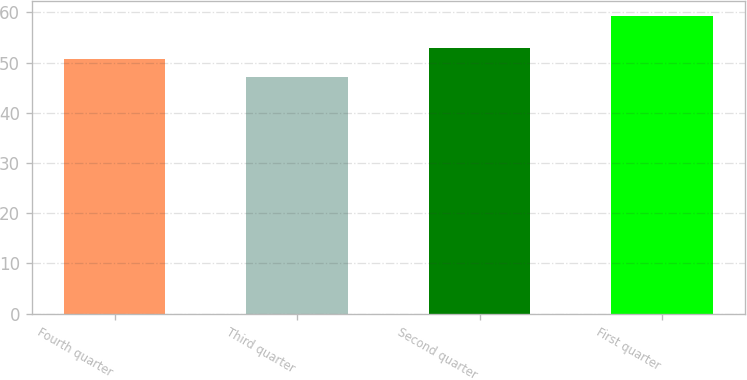Convert chart to OTSL. <chart><loc_0><loc_0><loc_500><loc_500><bar_chart><fcel>Fourth quarter<fcel>Third quarter<fcel>Second quarter<fcel>First quarter<nl><fcel>50.63<fcel>47.21<fcel>52.87<fcel>59.2<nl></chart> 